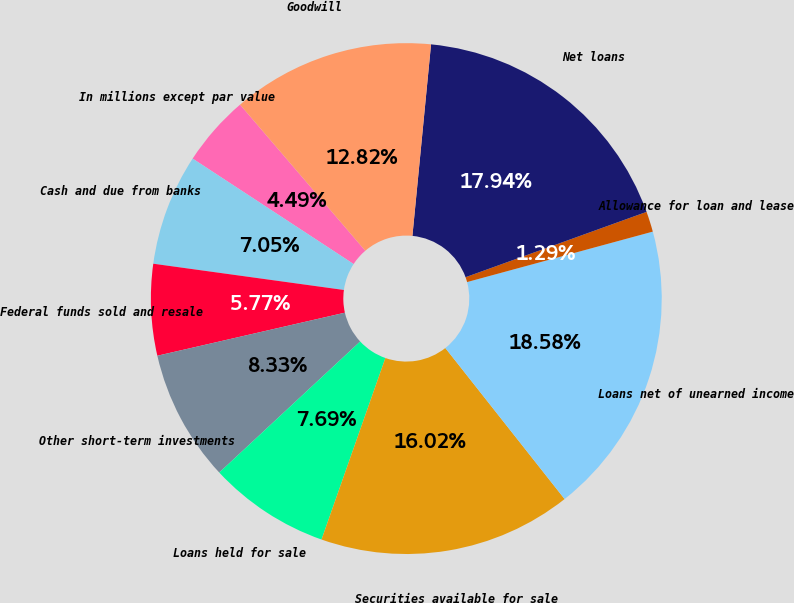Convert chart. <chart><loc_0><loc_0><loc_500><loc_500><pie_chart><fcel>In millions except par value<fcel>Cash and due from banks<fcel>Federal funds sold and resale<fcel>Other short-term investments<fcel>Loans held for sale<fcel>Securities available for sale<fcel>Loans net of unearned income<fcel>Allowance for loan and lease<fcel>Net loans<fcel>Goodwill<nl><fcel>4.49%<fcel>7.05%<fcel>5.77%<fcel>8.33%<fcel>7.69%<fcel>16.02%<fcel>18.58%<fcel>1.29%<fcel>17.94%<fcel>12.82%<nl></chart> 